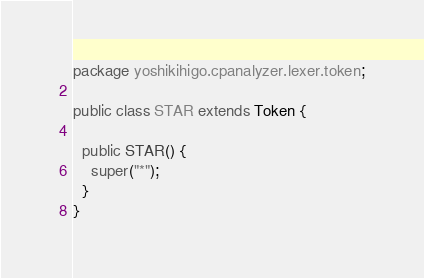Convert code to text. <code><loc_0><loc_0><loc_500><loc_500><_Java_>package yoshikihigo.cpanalyzer.lexer.token;

public class STAR extends Token {

  public STAR() {
    super("*");
  }
}
</code> 